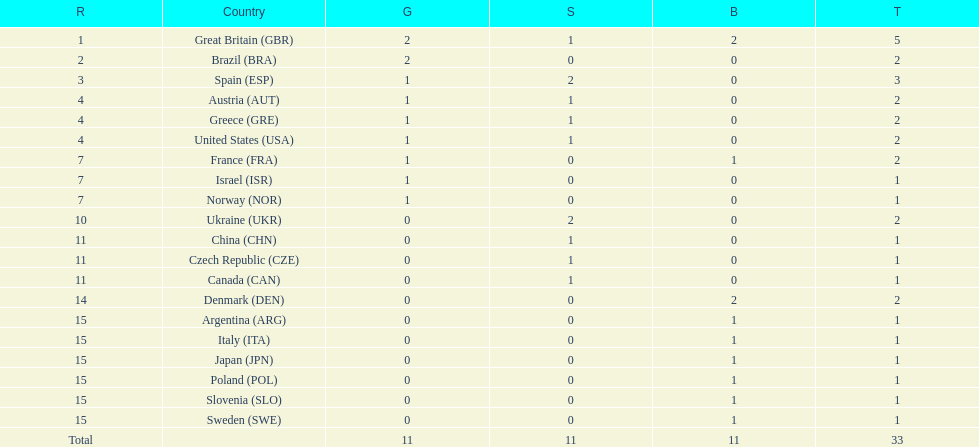What was the total number of medals won by united states? 2. 